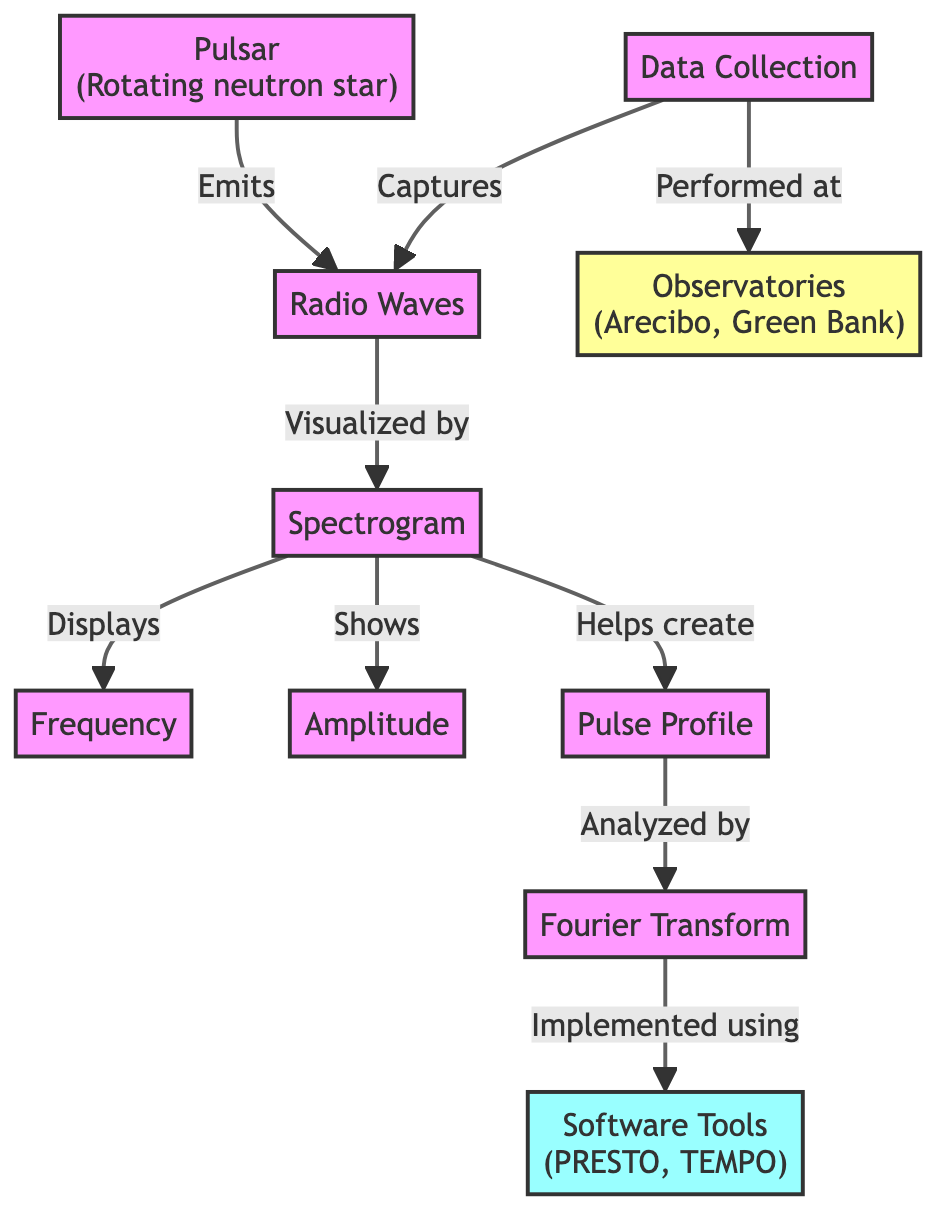What does a pulsar emit? The diagram indicates that a pulsar emits radio waves, explicitly connecting the node "Pulsar" to the node "Radio Waves."
Answer: Radio Waves What is visualized by a spectrogram? The arrow from "Radio Waves" to "Spectrogram" indicates that the spectrogram visualizes radio waves, making this the direct relationship in the diagram.
Answer: Radio Waves How many observatories are mentioned in the diagram? The diagram has one node labeled "Observatories" which lists "Arecibo" and "Green Bank." While the observatory node is singular, it contains two examples, making the count two.
Answer: 2 Which tools are used for implementing the Fourier Transform? The "Fourier Transform" node has a direct connection to "Software Tools," indicating that the Fourier Transform is implemented using the software tools PRESTO and TEMPO listed in that node.
Answer: Software Tools What does the spectrogram help to create? There is a directional arrow indicating that the "Spectrogram" helps create a "Pulse Profile," showing a clear relationship between these two entities in the diagram.
Answer: Pulse Profile How is data collection performed according to the diagram? The diagram shows that "Data Collection" captures radio waves while also being performed at "Observatories," indicating the method of collection and location role.
Answer: At Observatories Which phenomenon do pulsars belong to? The diagram's title and the "Pulsar" node define pulsars as rotating neutron stars, providing key information directly from the label itself.
Answer: Rotating neutron star What analysis is performed on the pulse profile? The diagram explicitly states that the "Pulse Profile" is analyzed by the "Fourier Transform," demonstrating the analytical relationship in the visual flow.
Answer: Fourier Transform What connects radio waves and the spectrogram? The directed edge labeled "Visualized by" establishes a connection that shows how radio waves are represented within a spectrogram.
Answer: Visualized by What type of waves are indicated in the spectrogram? The spectrogram displays aspects associated with amplitude and frequency related to the waves emitted from the pulsar, which are radio waves as established earlier.
Answer: Radio Waves 